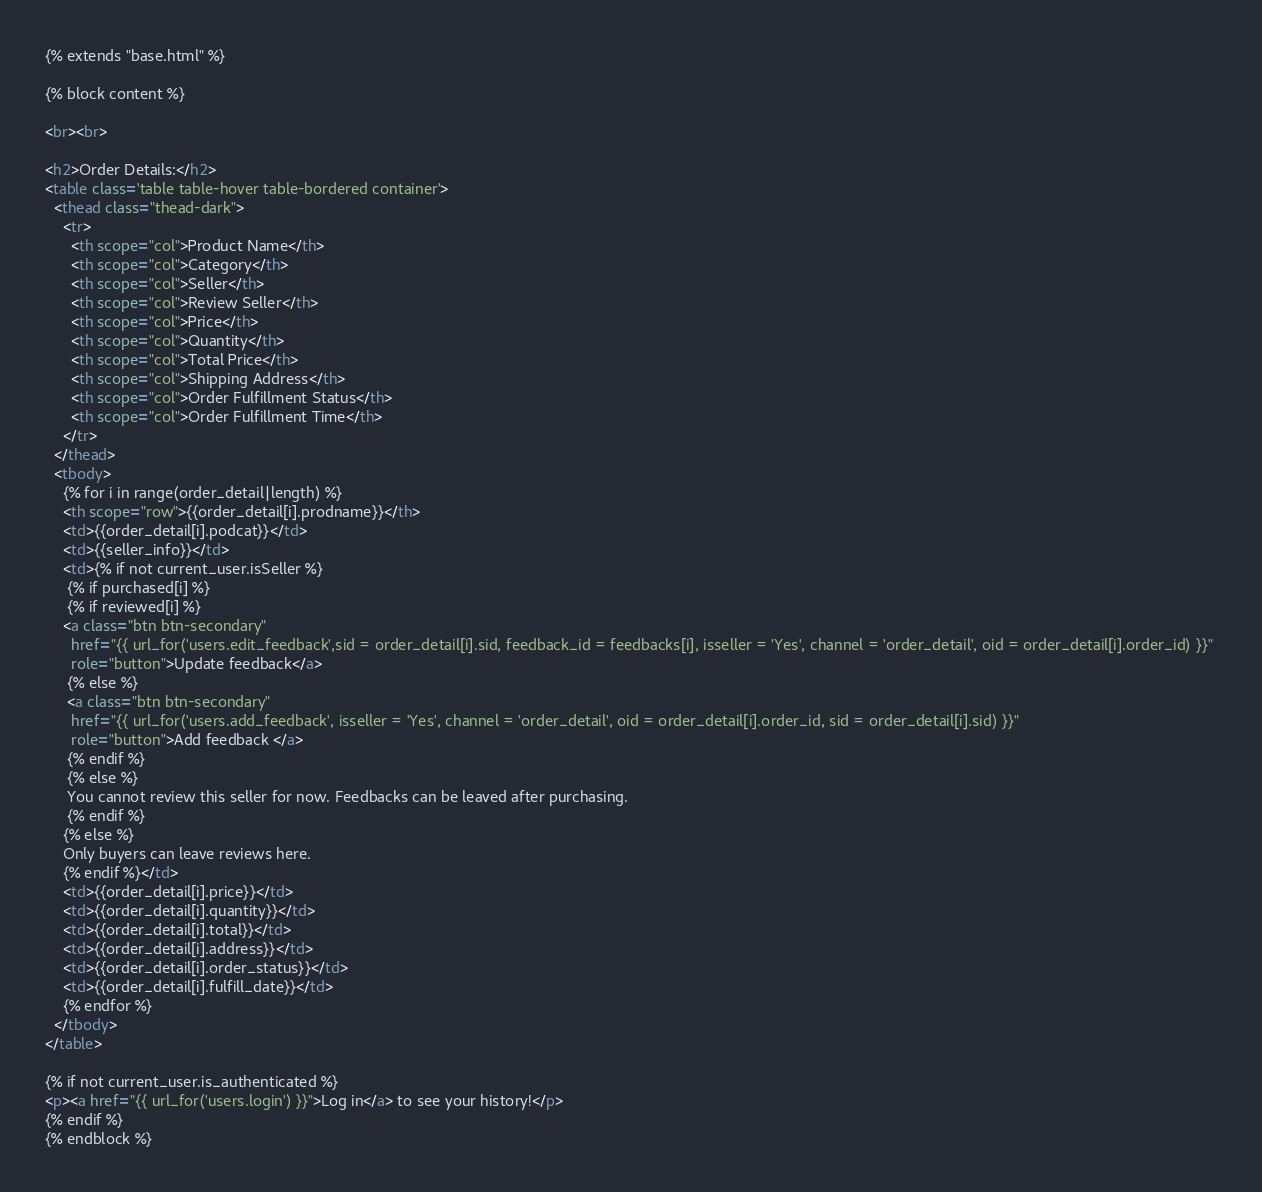Convert code to text. <code><loc_0><loc_0><loc_500><loc_500><_HTML_>{% extends "base.html" %}

{% block content %}

<br><br>

<h2>Order Details:</h2>
<table class='table table-hover table-bordered container'>
  <thead class="thead-dark">
    <tr>
      <th scope="col">Product Name</th>
      <th scope="col">Category</th>
      <th scope="col">Seller</th>
      <th scope="col">Review Seller</th>
      <th scope="col">Price</th>
      <th scope="col">Quantity</th>
      <th scope="col">Total Price</th>
      <th scope="col">Shipping Address</th>
      <th scope="col">Order Fulfillment Status</th>
      <th scope="col">Order Fulfillment Time</th>
    </tr>
  </thead>
  <tbody>
    {% for i in range(order_detail|length) %}
    <th scope="row">{{order_detail[i].prodname}}</th>
    <td>{{order_detail[i].podcat}}</td>
    <td>{{seller_info}}</td>
    <td>{% if not current_user.isSeller %}
     {% if purchased[i] %}
     {% if reviewed[i] %}
    <a class="btn btn-secondary" 
      href="{{ url_for('users.edit_feedback',sid = order_detail[i].sid, feedback_id = feedbacks[i], isseller = 'Yes', channel = 'order_detail', oid = order_detail[i].order_id) }}" 
      role="button">Update feedback</a>
     {% else %}
     <a class="btn btn-secondary" 
      href="{{ url_for('users.add_feedback', isseller = 'Yes', channel = 'order_detail', oid = order_detail[i].order_id, sid = order_detail[i].sid) }}" 
      role="button">Add feedback </a>
     {% endif %}
     {% else %}
     You cannot review this seller for now. Feedbacks can be leaved after purchasing.
     {% endif %}
    {% else %}
    Only buyers can leave reviews here.
    {% endif %}</td>
    <td>{{order_detail[i].price}}</td>
    <td>{{order_detail[i].quantity}}</td>
    <td>{{order_detail[i].total}}</td>
    <td>{{order_detail[i].address}}</td>
    <td>{{order_detail[i].order_status}}</td>
    <td>{{order_detail[i].fulfill_date}}</td>
    {% endfor %}
  </tbody>
</table>

{% if not current_user.is_authenticated %}
<p><a href="{{ url_for('users.login') }}">Log in</a> to see your history!</p>
{% endif %}
{% endblock %}
</code> 